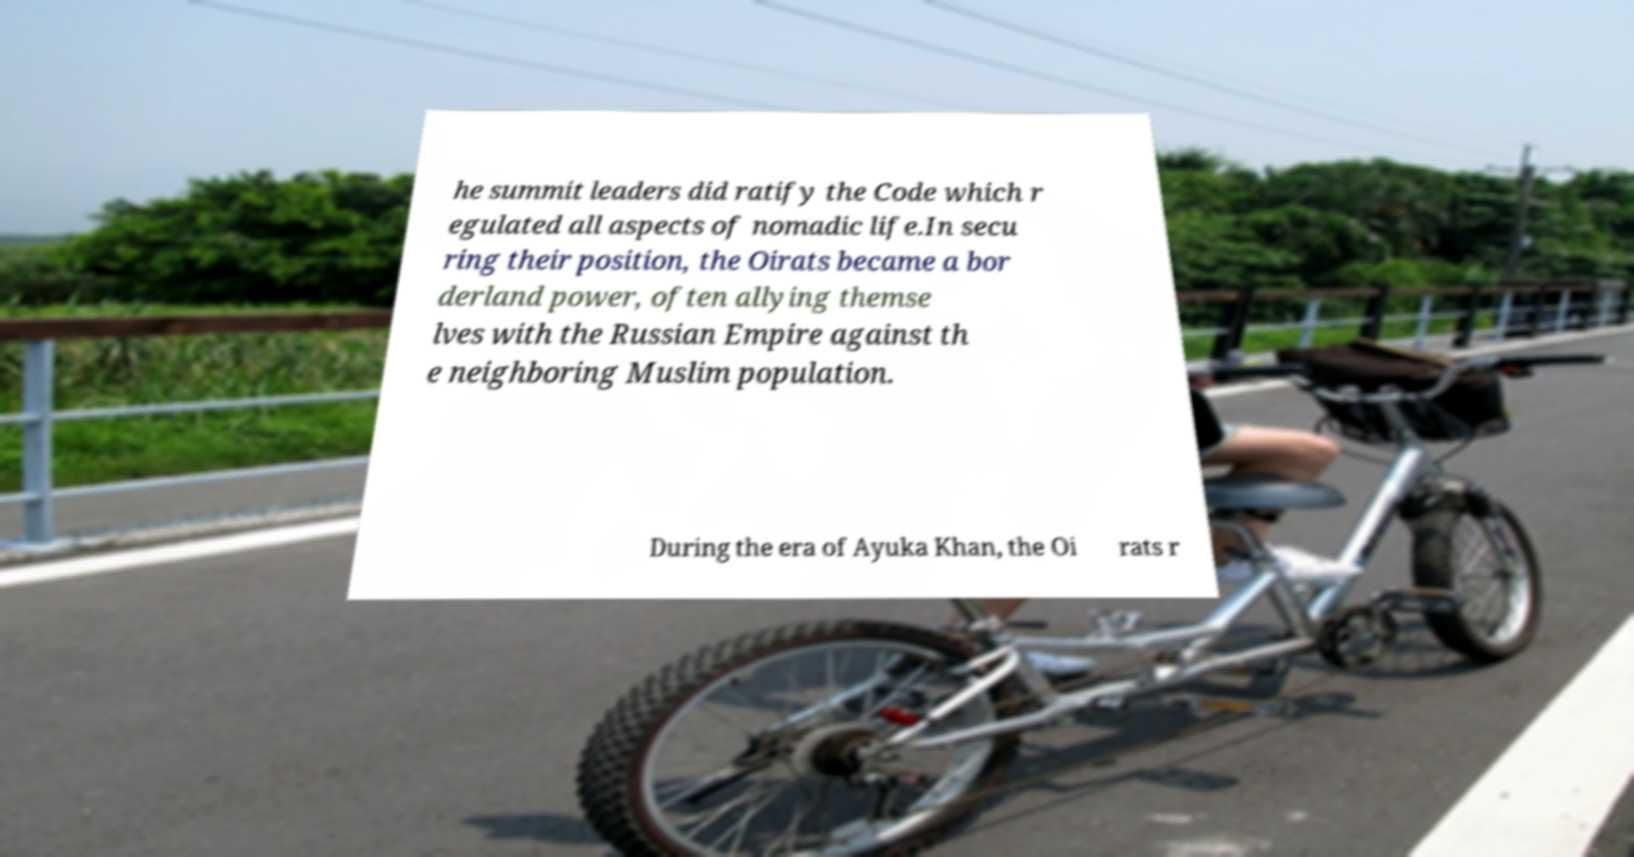There's text embedded in this image that I need extracted. Can you transcribe it verbatim? he summit leaders did ratify the Code which r egulated all aspects of nomadic life.In secu ring their position, the Oirats became a bor derland power, often allying themse lves with the Russian Empire against th e neighboring Muslim population. During the era of Ayuka Khan, the Oi rats r 